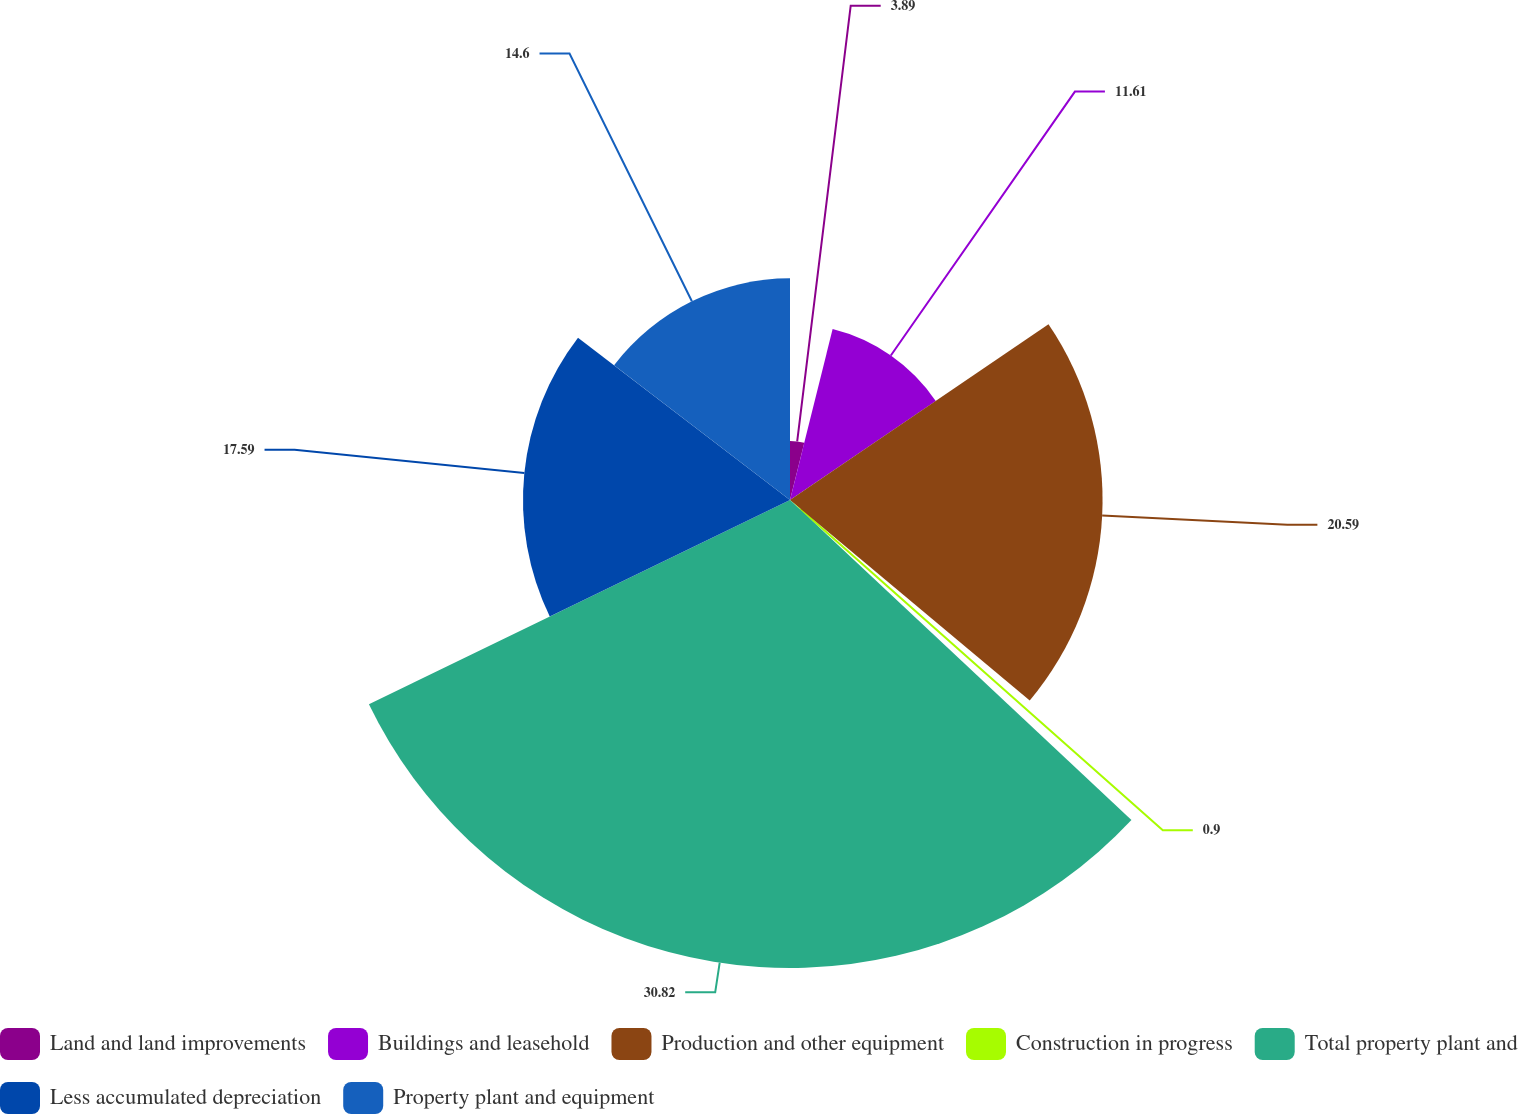Convert chart to OTSL. <chart><loc_0><loc_0><loc_500><loc_500><pie_chart><fcel>Land and land improvements<fcel>Buildings and leasehold<fcel>Production and other equipment<fcel>Construction in progress<fcel>Total property plant and<fcel>Less accumulated depreciation<fcel>Property plant and equipment<nl><fcel>3.89%<fcel>11.61%<fcel>20.59%<fcel>0.9%<fcel>30.83%<fcel>17.59%<fcel>14.6%<nl></chart> 